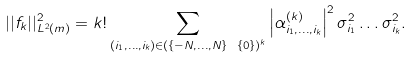Convert formula to latex. <formula><loc_0><loc_0><loc_500><loc_500>| | f _ { k } | | _ { L ^ { 2 } ( m ) } ^ { 2 } = k ! \sum _ { ( i _ { 1 } , \dots , i _ { k } ) \in ( \{ - N , \dots , N \} \ \{ 0 \} ) ^ { k } } \left | \alpha _ { i _ { 1 } , \dots , i _ { k } } ^ { ( k ) } \right | ^ { 2 } \sigma _ { i _ { 1 } } ^ { 2 } \dots \sigma _ { i _ { k } } ^ { 2 } .</formula> 